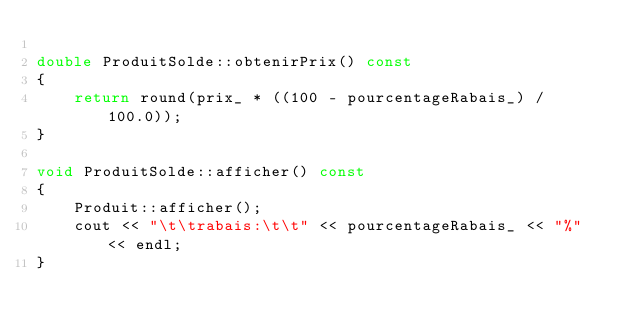<code> <loc_0><loc_0><loc_500><loc_500><_C++_>
double ProduitSolde::obtenirPrix() const
{
    return round(prix_ * ((100 - pourcentageRabais_) / 100.0));
}

void ProduitSolde::afficher() const
{
    Produit::afficher();
    cout << "\t\trabais:\t\t" << pourcentageRabais_ << "%" << endl;
}
</code> 